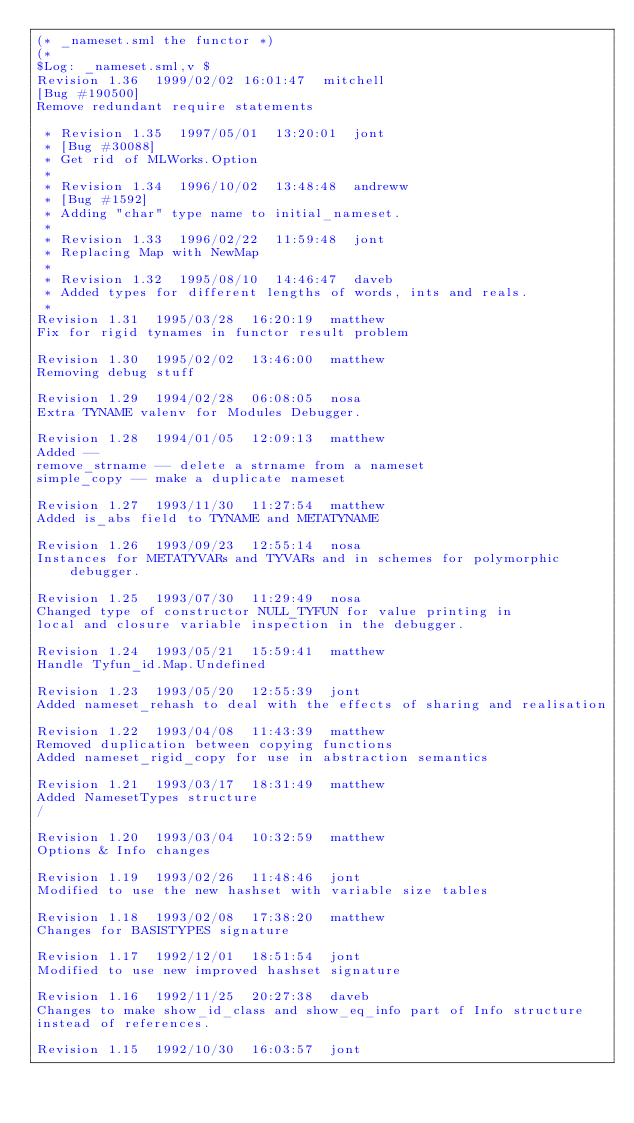<code> <loc_0><loc_0><loc_500><loc_500><_SML_>(* _nameset.sml the functor *)
(*
$Log: _nameset.sml,v $
Revision 1.36  1999/02/02 16:01:47  mitchell
[Bug #190500]
Remove redundant require statements

 * Revision 1.35  1997/05/01  13:20:01  jont
 * [Bug #30088]
 * Get rid of MLWorks.Option
 *
 * Revision 1.34  1996/10/02  13:48:48  andreww
 * [Bug #1592]
 * Adding "char" type name to initial_nameset.
 *
 * Revision 1.33  1996/02/22  11:59:48  jont
 * Replacing Map with NewMap
 *
 * Revision 1.32  1995/08/10  14:46:47  daveb
 * Added types for different lengths of words, ints and reals.
 *
Revision 1.31  1995/03/28  16:20:19  matthew
Fix for rigid tynames in functor result problem

Revision 1.30  1995/02/02  13:46:00  matthew
Removing debug stuff

Revision 1.29  1994/02/28  06:08:05  nosa
Extra TYNAME valenv for Modules Debugger.

Revision 1.28  1994/01/05  12:09:13  matthew
Added --
remove_strname -- delete a strname from a nameset
simple_copy -- make a duplicate nameset

Revision 1.27  1993/11/30  11:27:54  matthew
Added is_abs field to TYNAME and METATYNAME

Revision 1.26  1993/09/23  12:55:14  nosa
Instances for METATYVARs and TYVARs and in schemes for polymorphic debugger.

Revision 1.25  1993/07/30  11:29:49  nosa
Changed type of constructor NULL_TYFUN for value printing in
local and closure variable inspection in the debugger.

Revision 1.24  1993/05/21  15:59:41  matthew
Handle Tyfun_id.Map.Undefined

Revision 1.23  1993/05/20  12:55:39  jont
Added nameset_rehash to deal with the effects of sharing and realisation

Revision 1.22  1993/04/08  11:43:39  matthew
Removed duplication between copying functions
Added nameset_rigid_copy for use in abstraction semantics

Revision 1.21  1993/03/17  18:31:49  matthew
Added NamesetTypes structure
/

Revision 1.20  1993/03/04  10:32:59  matthew
Options & Info changes

Revision 1.19  1993/02/26  11:48:46  jont
Modified to use the new hashset with variable size tables

Revision 1.18  1993/02/08  17:38:20  matthew
Changes for BASISTYPES signature

Revision 1.17  1992/12/01  18:51:54  jont
Modified to use new improved hashset signature

Revision 1.16  1992/11/25  20:27:38  daveb
Changes to make show_id_class and show_eq_info part of Info structure
instead of references.

Revision 1.15  1992/10/30  16:03:57  jont</code> 